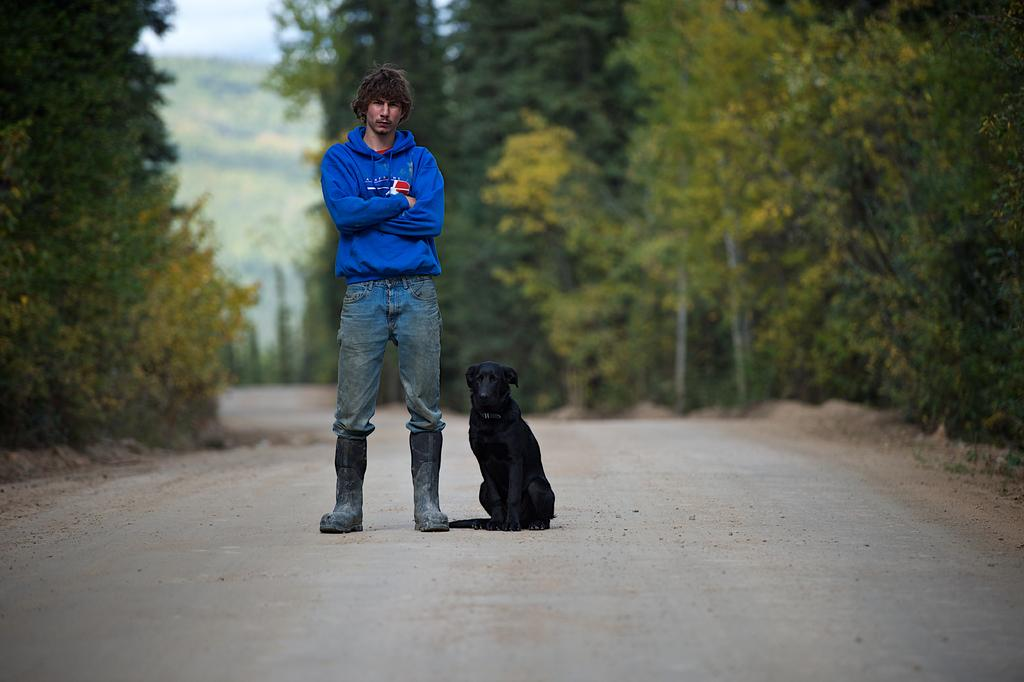What is the main subject of the image? The main subject of the image is a man. Can you describe the man's clothing? The man is wearing a blue hoodie. Where is the man positioned in the image? The man is standing in the front. What other living creature is present in the image? There is a black dog in the image. What is the dog doing in the image? The dog is sitting on the road. What can be seen in the background of the image? There are huge trees in the background of the image. What type of drug can be seen in the man's hand in the image? There is no drug present in the image; the man is not holding anything in his hand. 